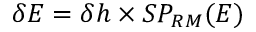Convert formula to latex. <formula><loc_0><loc_0><loc_500><loc_500>\delta E = \delta h \times S P _ { R M } ( E )</formula> 